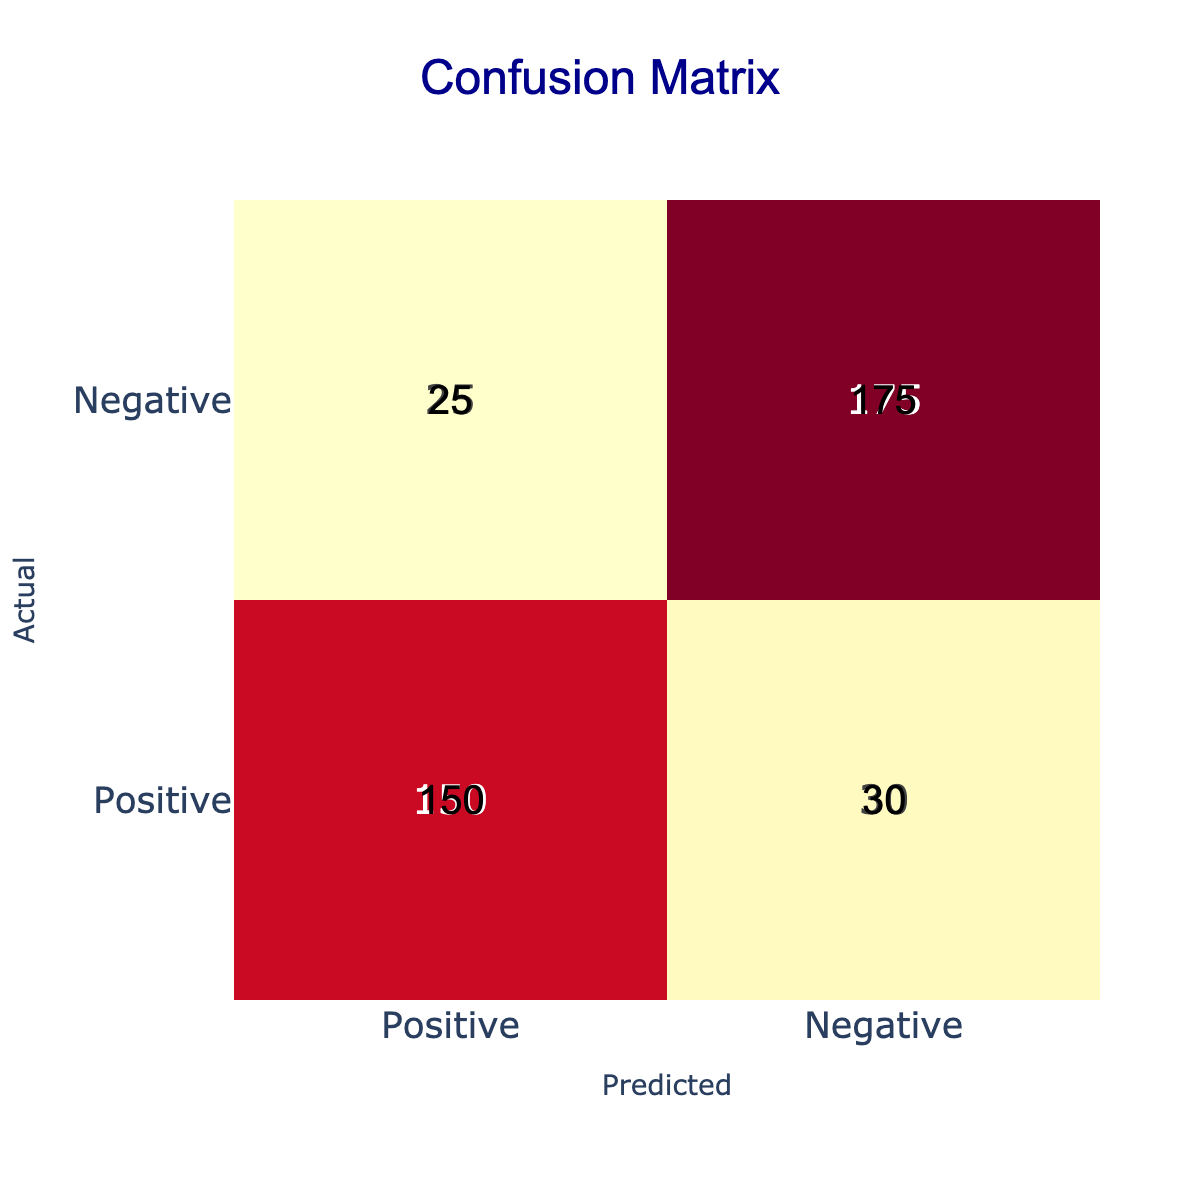What is the count of true positives? True positives are the instances where the actual sentiment was positive and the predicted sentiment was also positive. From the table, there are 150 true positives listed under the "Positive" row and "Positive" column.
Answer: 150 How many reviews were predicted as negative? To find the total reviews predicted as negative, we need to sum the counts in the column for "Negative" predictions. The counts are 30 (actual positive predicted negative) + 175 (actual negative predicted negative), which totals to 205.
Answer: 205 What is the total number of reviews? The total number of reviews can be calculated by summing all the counts in the table. Adding 150 (TP) + 30 (FN) + 25 (FP) + 175 (TN) gives a total of 380 reviews.
Answer: 380 Is the number of true negatives greater than the number of true positives? True negatives, which are the cases where actual and predicted sentiments are both negative, total 175. True positives, where both sentiments are positive, total 150. Since 175 is greater than 150, the statement is true.
Answer: Yes What is the precision for the positive class? Precision is calculated as the ratio of true positives to the total predicted positives. The formula is TP / (TP + FP). From the table, TP is 150 and FP is 25. Thus, precision = 150 / (150 + 25) = 150 / 175 = 0.857.
Answer: 0.857 What is the count of false negatives? False negatives are the cases where the actual sentiment was positive, but the predicted sentiment was negative. This is represented in the table as 30.
Answer: 30 What is the recall for the negative class? Recall for the negative class is calculated by taking the true negatives over the total actual negatives. Total actual negatives = FN + TN = 25 + 175 = 200. Thus, recall = TN / (FN + TN) = 175 / 200 = 0.875.
Answer: 0.875 How many more reviews were correctly predicted as negative than incorrectly predicted as positive? Correctly predicted negatives are 175 (TN) and incorrectly predicted positives are 25 (FP). The difference is 175 - 25, which equals 150.
Answer: 150 What percentage of the total reviews were classified correctly? To find the percentage classified correctly, we sum the true positives and true negatives (150 + 175 = 325) and divide by the total number of reviews (380), then multiply by 100. Thus, (325 / 380) * 100 = 85.53%.
Answer: 85.53% 